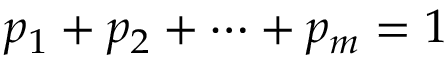Convert formula to latex. <formula><loc_0><loc_0><loc_500><loc_500>p _ { 1 } + p _ { 2 } + \cdots + p _ { m } = 1</formula> 